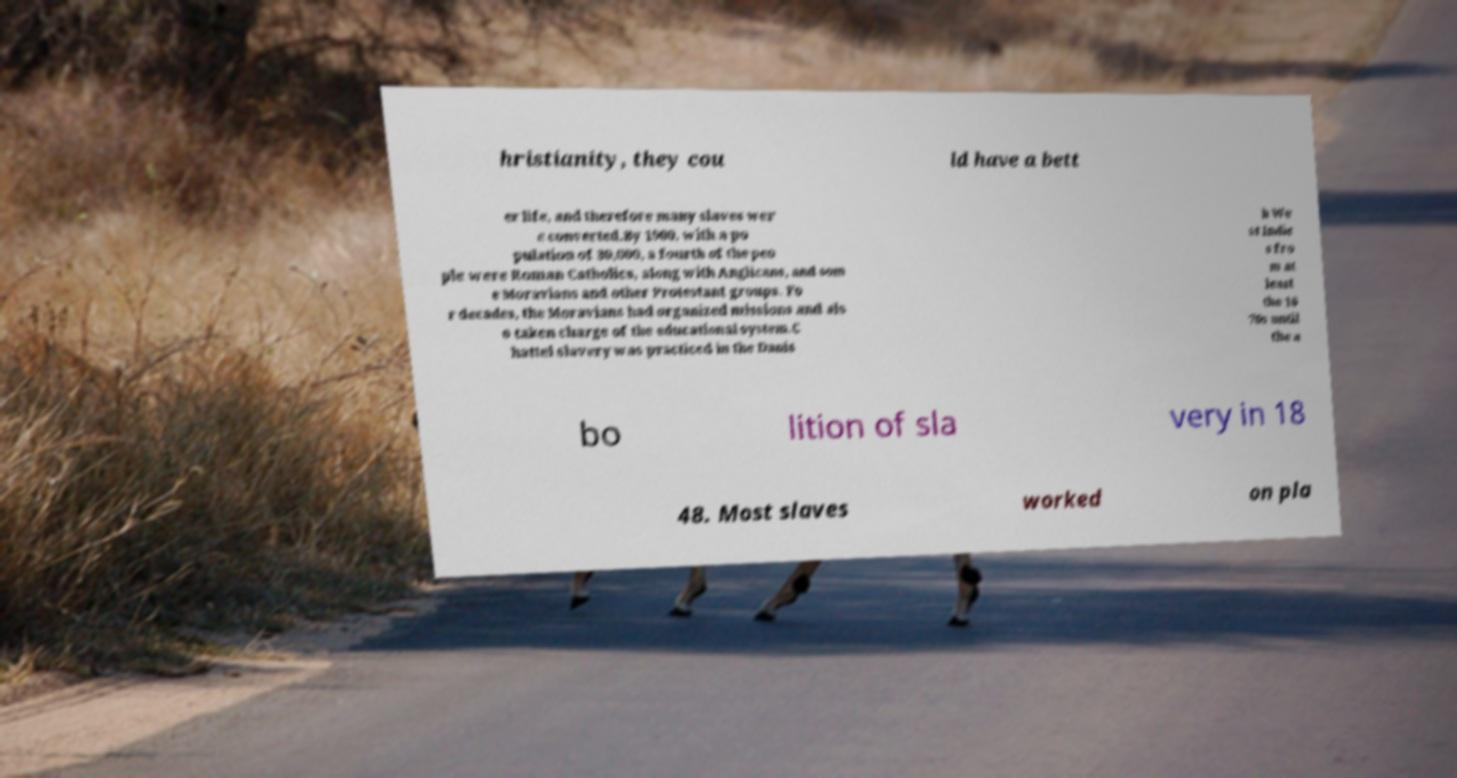What messages or text are displayed in this image? I need them in a readable, typed format. hristianity, they cou ld have a bett er life, and therefore many slaves wer e converted.By 1900, with a po pulation of 30,000, a fourth of the peo ple were Roman Catholics, along with Anglicans, and som e Moravians and other Protestant groups. Fo r decades, the Moravians had organized missions and als o taken charge of the educational system.C hattel slavery was practiced in the Danis h We st Indie s fro m at least the 16 70s until the a bo lition of sla very in 18 48. Most slaves worked on pla 